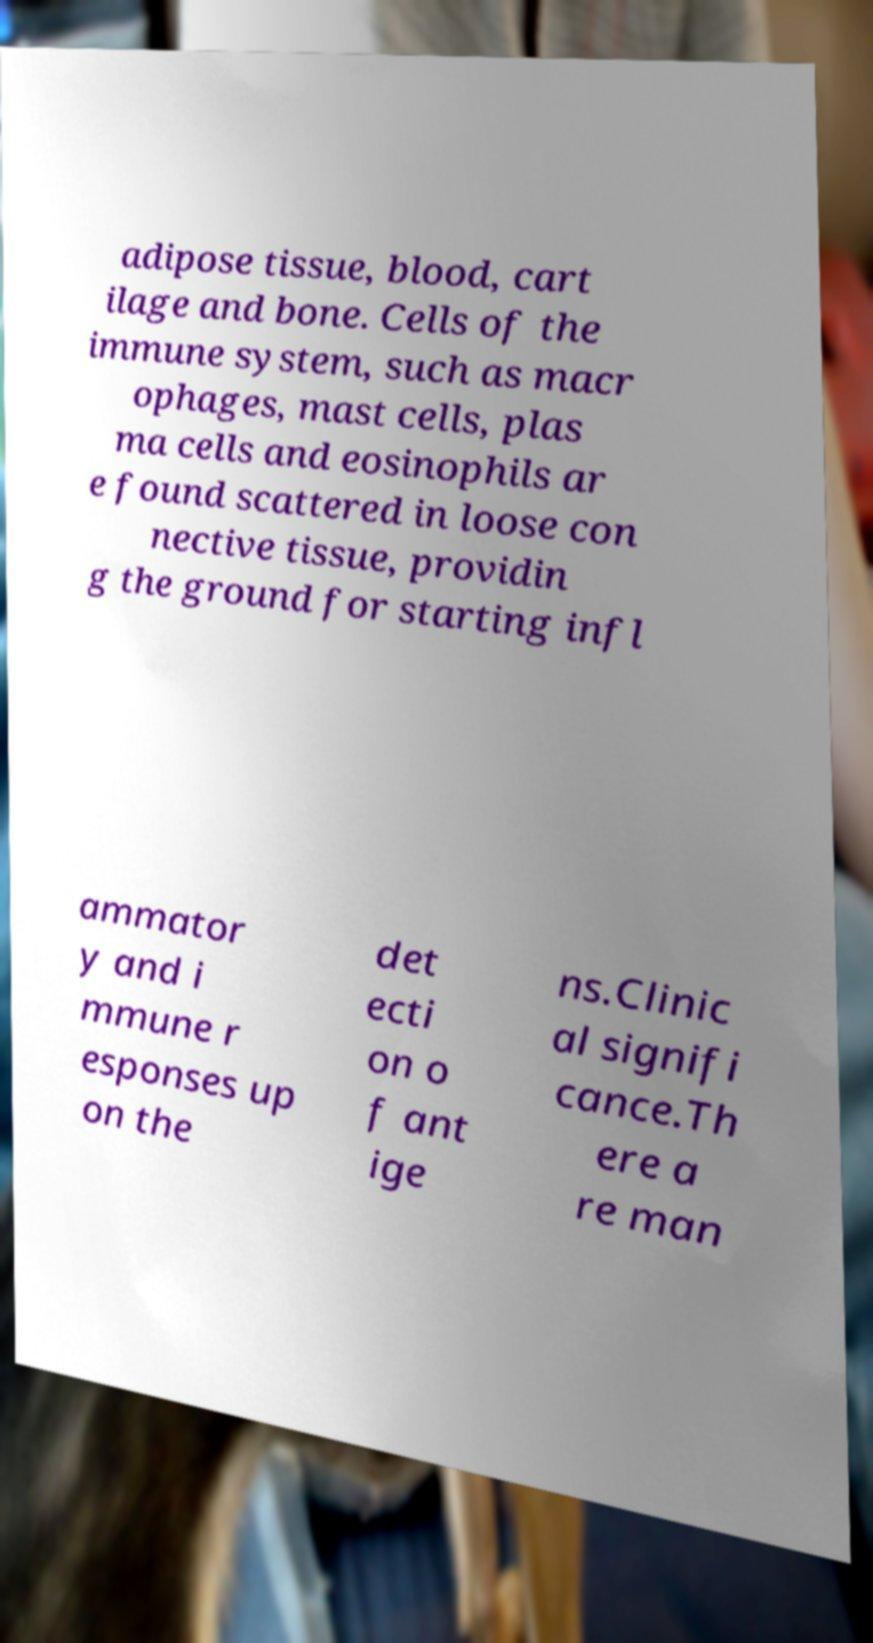Could you extract and type out the text from this image? adipose tissue, blood, cart ilage and bone. Cells of the immune system, such as macr ophages, mast cells, plas ma cells and eosinophils ar e found scattered in loose con nective tissue, providin g the ground for starting infl ammator y and i mmune r esponses up on the det ecti on o f ant ige ns.Clinic al signifi cance.Th ere a re man 